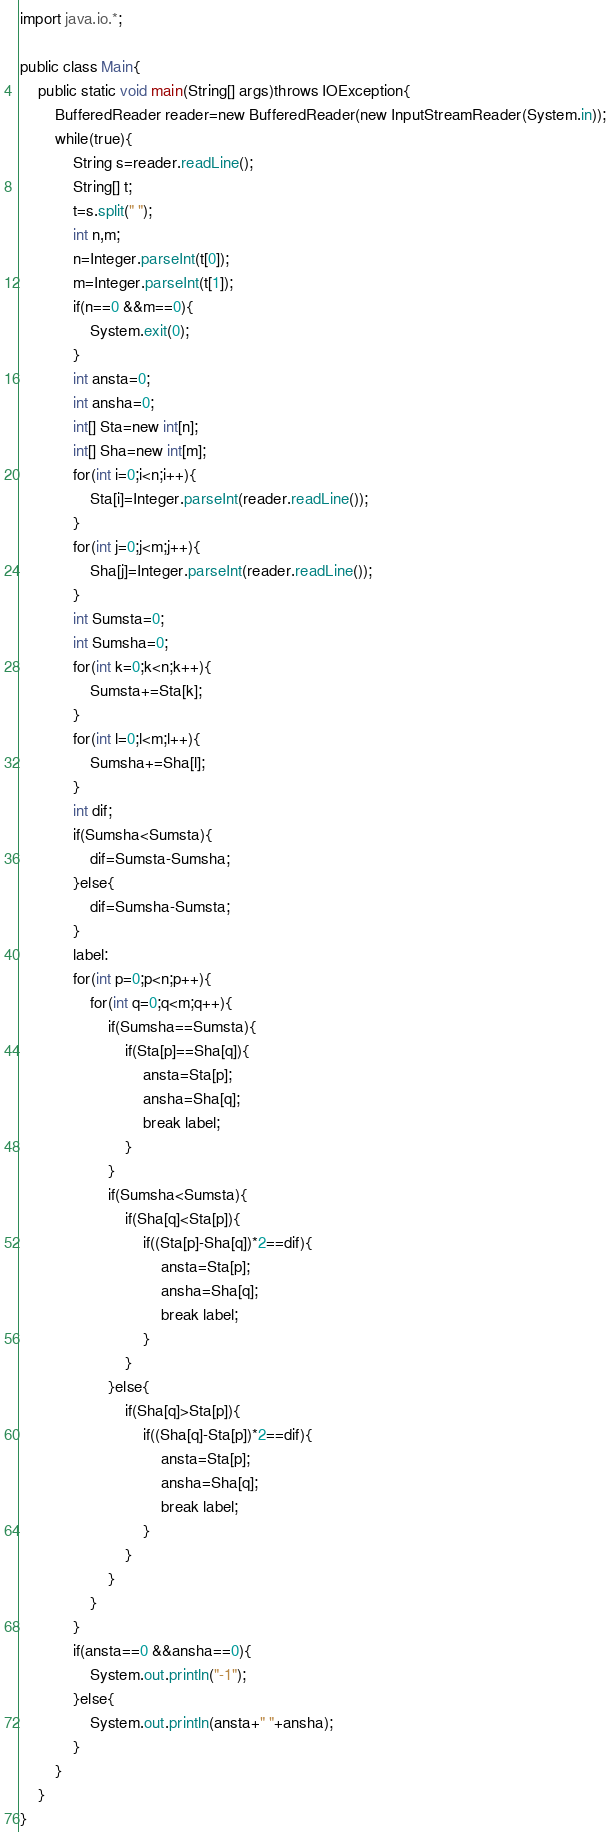Convert code to text. <code><loc_0><loc_0><loc_500><loc_500><_Java_>import java.io.*;

public class Main{
	public static void main(String[] args)throws IOException{
		BufferedReader reader=new BufferedReader(new InputStreamReader(System.in));
		while(true){
			String s=reader.readLine();
			String[] t;
			t=s.split(" ");
			int n,m;
			n=Integer.parseInt(t[0]);
			m=Integer.parseInt(t[1]);
			if(n==0 &&m==0){
				System.exit(0);
			}
			int ansta=0;
			int ansha=0;
			int[] Sta=new int[n];
			int[] Sha=new int[m];
			for(int i=0;i<n;i++){
				Sta[i]=Integer.parseInt(reader.readLine());
			}
			for(int j=0;j<m;j++){
				Sha[j]=Integer.parseInt(reader.readLine());
			}
			int Sumsta=0;
			int Sumsha=0;
			for(int k=0;k<n;k++){
				Sumsta+=Sta[k];
			}
			for(int l=0;l<m;l++){
				Sumsha+=Sha[l];
			}
			int dif;
			if(Sumsha<Sumsta){
				dif=Sumsta-Sumsha;
			}else{
				dif=Sumsha-Sumsta;
			}
			label:
			for(int p=0;p<n;p++){
				for(int q=0;q<m;q++){
					if(Sumsha==Sumsta){
						if(Sta[p]==Sha[q]){
							ansta=Sta[p];
							ansha=Sha[q];
							break label;
						}
					}
					if(Sumsha<Sumsta){
						if(Sha[q]<Sta[p]){
							if((Sta[p]-Sha[q])*2==dif){
								ansta=Sta[p];
								ansha=Sha[q];
								break label;
							}
						}
					}else{
						if(Sha[q]>Sta[p]){
							if((Sha[q]-Sta[p])*2==dif){
								ansta=Sta[p];
								ansha=Sha[q];
								break label;
							}
						}
					}
				}
			}
			if(ansta==0 &&ansha==0){
				System.out.println("-1");
			}else{
				System.out.println(ansta+" "+ansha);
			}
		}
	}
}	</code> 